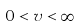<formula> <loc_0><loc_0><loc_500><loc_500>0 < v < \infty</formula> 